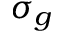Convert formula to latex. <formula><loc_0><loc_0><loc_500><loc_500>\sigma _ { g }</formula> 